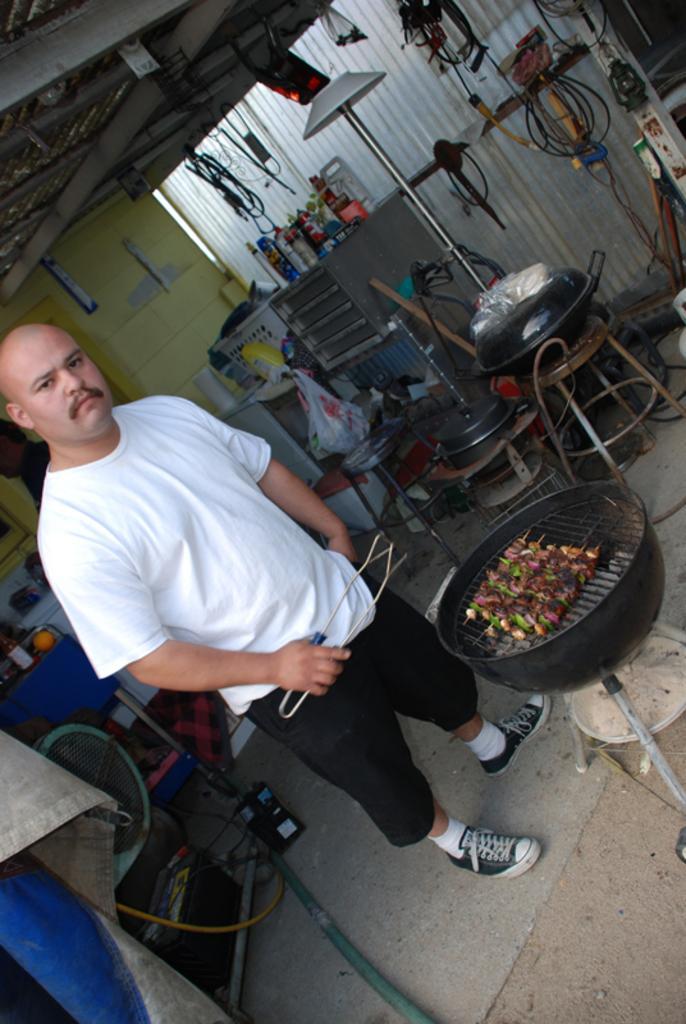Can you describe this image briefly? In the foreground of the picture there is a person and a stove, on the stove there are food item and grill. On the left there are drum, mat, pipe and other objects. In the background there are bottles, tools, covers, lamps, cables and many other objects. On the right there are cables and some instruments. 